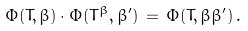<formula> <loc_0><loc_0><loc_500><loc_500>\Phi ( T , \beta ) \cdot \Phi ( T ^ { \beta } , \beta ^ { \prime } ) \, = \, \Phi ( T , \beta \beta ^ { \prime } ) \, .</formula> 